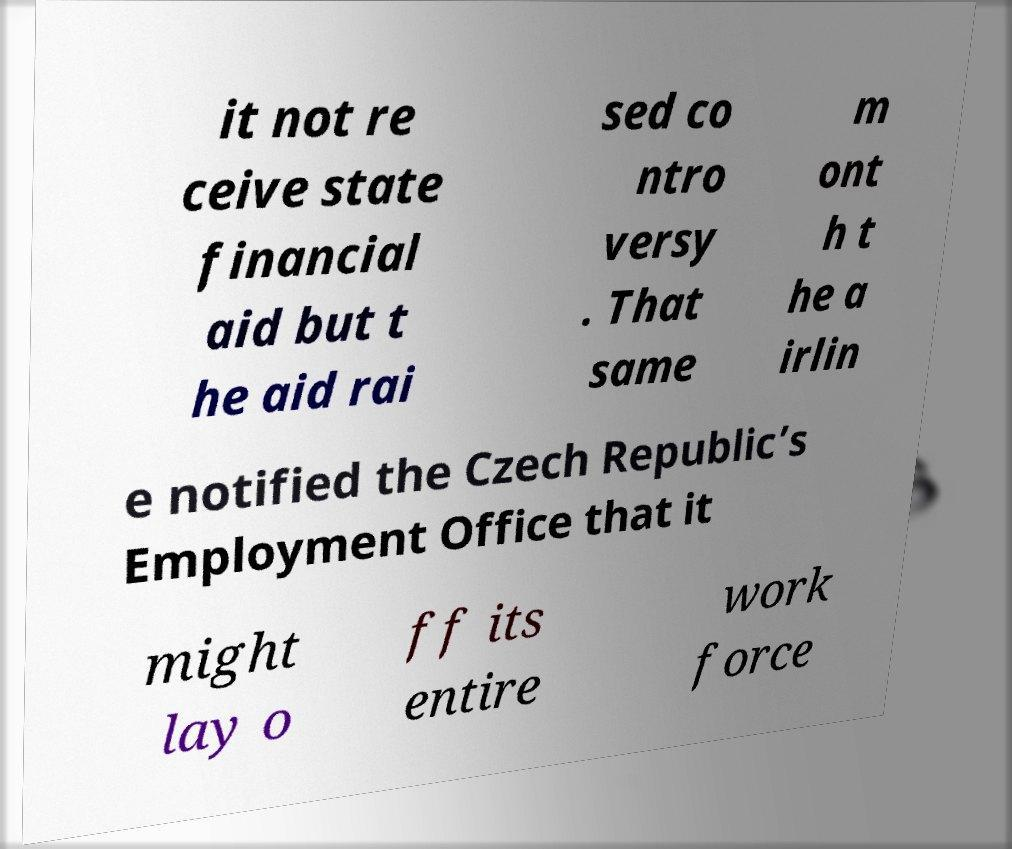Can you accurately transcribe the text from the provided image for me? it not re ceive state financial aid but t he aid rai sed co ntro versy . That same m ont h t he a irlin e notified the Czech Republic’s Employment Office that it might lay o ff its entire work force 